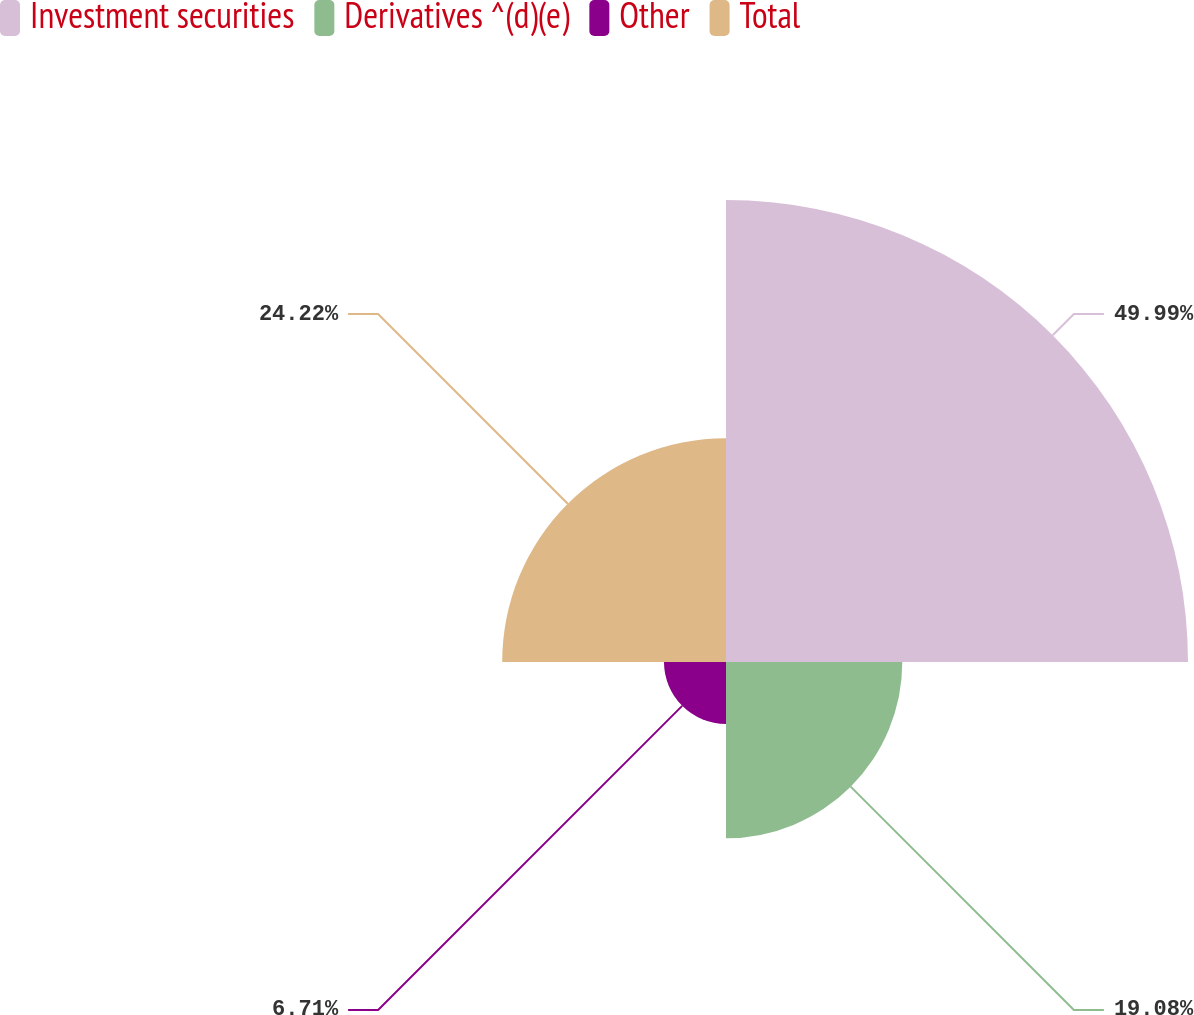<chart> <loc_0><loc_0><loc_500><loc_500><pie_chart><fcel>Investment securities<fcel>Derivatives ^(d)(e)<fcel>Other<fcel>Total<nl><fcel>50.0%<fcel>19.08%<fcel>6.71%<fcel>24.22%<nl></chart> 